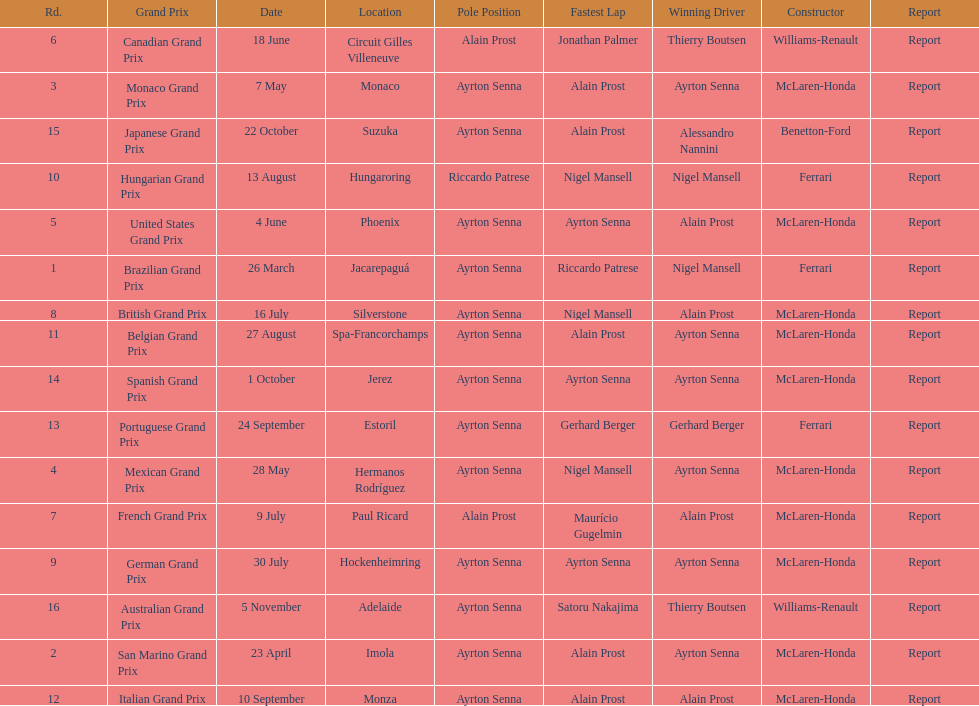Help me parse the entirety of this table. {'header': ['Rd.', 'Grand Prix', 'Date', 'Location', 'Pole Position', 'Fastest Lap', 'Winning Driver', 'Constructor', 'Report'], 'rows': [['6', 'Canadian Grand Prix', '18 June', 'Circuit Gilles Villeneuve', 'Alain Prost', 'Jonathan Palmer', 'Thierry Boutsen', 'Williams-Renault', 'Report'], ['3', 'Monaco Grand Prix', '7 May', 'Monaco', 'Ayrton Senna', 'Alain Prost', 'Ayrton Senna', 'McLaren-Honda', 'Report'], ['15', 'Japanese Grand Prix', '22 October', 'Suzuka', 'Ayrton Senna', 'Alain Prost', 'Alessandro Nannini', 'Benetton-Ford', 'Report'], ['10', 'Hungarian Grand Prix', '13 August', 'Hungaroring', 'Riccardo Patrese', 'Nigel Mansell', 'Nigel Mansell', 'Ferrari', 'Report'], ['5', 'United States Grand Prix', '4 June', 'Phoenix', 'Ayrton Senna', 'Ayrton Senna', 'Alain Prost', 'McLaren-Honda', 'Report'], ['1', 'Brazilian Grand Prix', '26 March', 'Jacarepaguá', 'Ayrton Senna', 'Riccardo Patrese', 'Nigel Mansell', 'Ferrari', 'Report'], ['8', 'British Grand Prix', '16 July', 'Silverstone', 'Ayrton Senna', 'Nigel Mansell', 'Alain Prost', 'McLaren-Honda', 'Report'], ['11', 'Belgian Grand Prix', '27 August', 'Spa-Francorchamps', 'Ayrton Senna', 'Alain Prost', 'Ayrton Senna', 'McLaren-Honda', 'Report'], ['14', 'Spanish Grand Prix', '1 October', 'Jerez', 'Ayrton Senna', 'Ayrton Senna', 'Ayrton Senna', 'McLaren-Honda', 'Report'], ['13', 'Portuguese Grand Prix', '24 September', 'Estoril', 'Ayrton Senna', 'Gerhard Berger', 'Gerhard Berger', 'Ferrari', 'Report'], ['4', 'Mexican Grand Prix', '28 May', 'Hermanos Rodríguez', 'Ayrton Senna', 'Nigel Mansell', 'Ayrton Senna', 'McLaren-Honda', 'Report'], ['7', 'French Grand Prix', '9 July', 'Paul Ricard', 'Alain Prost', 'Maurício Gugelmin', 'Alain Prost', 'McLaren-Honda', 'Report'], ['9', 'German Grand Prix', '30 July', 'Hockenheimring', 'Ayrton Senna', 'Ayrton Senna', 'Ayrton Senna', 'McLaren-Honda', 'Report'], ['16', 'Australian Grand Prix', '5 November', 'Adelaide', 'Ayrton Senna', 'Satoru Nakajima', 'Thierry Boutsen', 'Williams-Renault', 'Report'], ['2', 'San Marino Grand Prix', '23 April', 'Imola', 'Ayrton Senna', 'Alain Prost', 'Ayrton Senna', 'McLaren-Honda', 'Report'], ['12', 'Italian Grand Prix', '10 September', 'Monza', 'Ayrton Senna', 'Alain Prost', 'Alain Prost', 'McLaren-Honda', 'Report']]} How many races occurred before alain prost won a pole position? 5. 